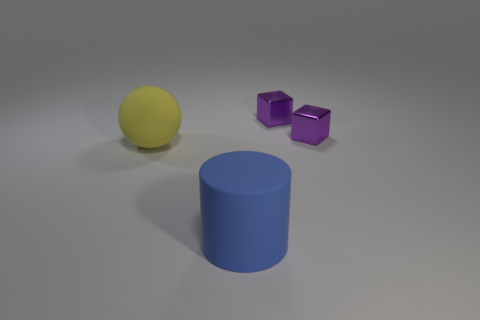Add 2 metallic objects. How many objects exist? 6 Subtract all balls. How many objects are left? 3 Subtract 0 blue balls. How many objects are left? 4 Subtract 1 balls. How many balls are left? 0 Subtract all gray balls. Subtract all blue cylinders. How many balls are left? 1 Subtract all small gray matte things. Subtract all tiny purple objects. How many objects are left? 2 Add 4 tiny purple metallic objects. How many tiny purple metallic objects are left? 6 Add 4 large balls. How many large balls exist? 5 